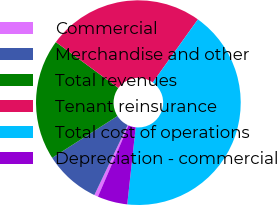Convert chart. <chart><loc_0><loc_0><loc_500><loc_500><pie_chart><fcel>Commercial<fcel>Merchandise and other<fcel>Total revenues<fcel>Tenant reinsurance<fcel>Total cost of operations<fcel>Depreciation - commercial<nl><fcel>0.61%<fcel>8.86%<fcel>19.15%<fcel>24.8%<fcel>41.85%<fcel>4.73%<nl></chart> 